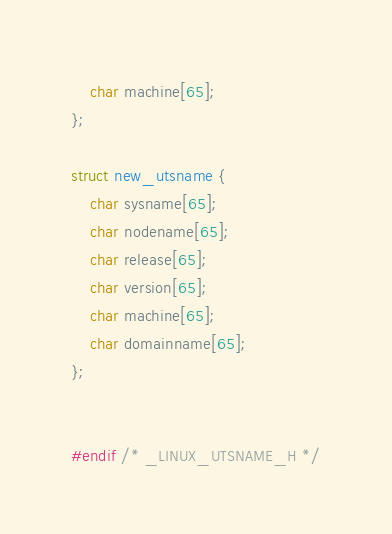<code> <loc_0><loc_0><loc_500><loc_500><_C_>	char machine[65];
};

struct new_utsname {
	char sysname[65];
	char nodename[65];
	char release[65];
	char version[65];
	char machine[65];
	char domainname[65];
};


#endif /* _LINUX_UTSNAME_H */
</code> 